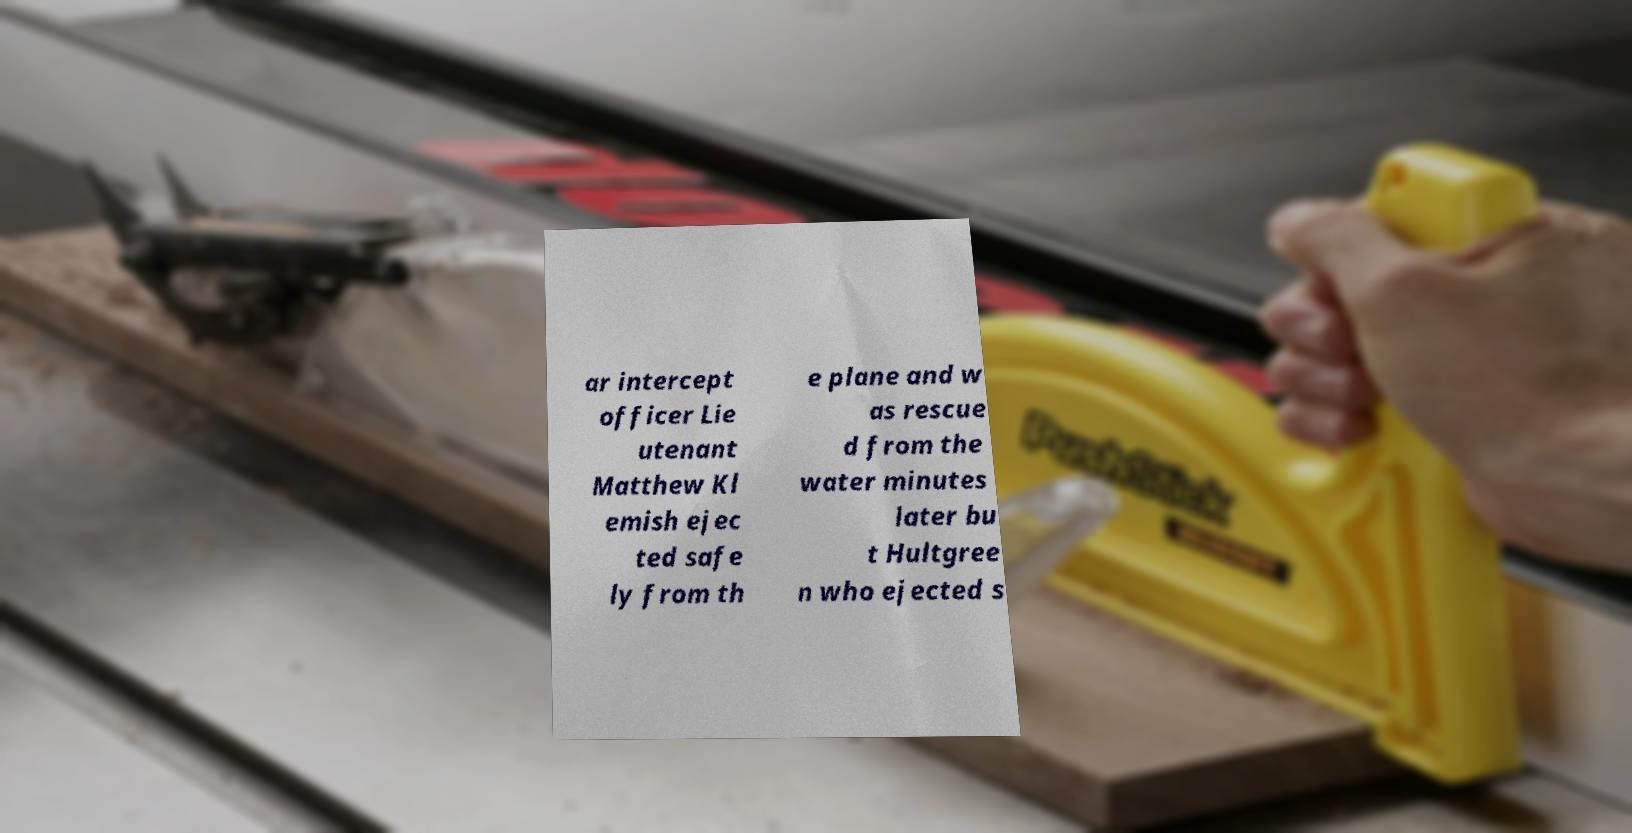Please identify and transcribe the text found in this image. ar intercept officer Lie utenant Matthew Kl emish ejec ted safe ly from th e plane and w as rescue d from the water minutes later bu t Hultgree n who ejected s 